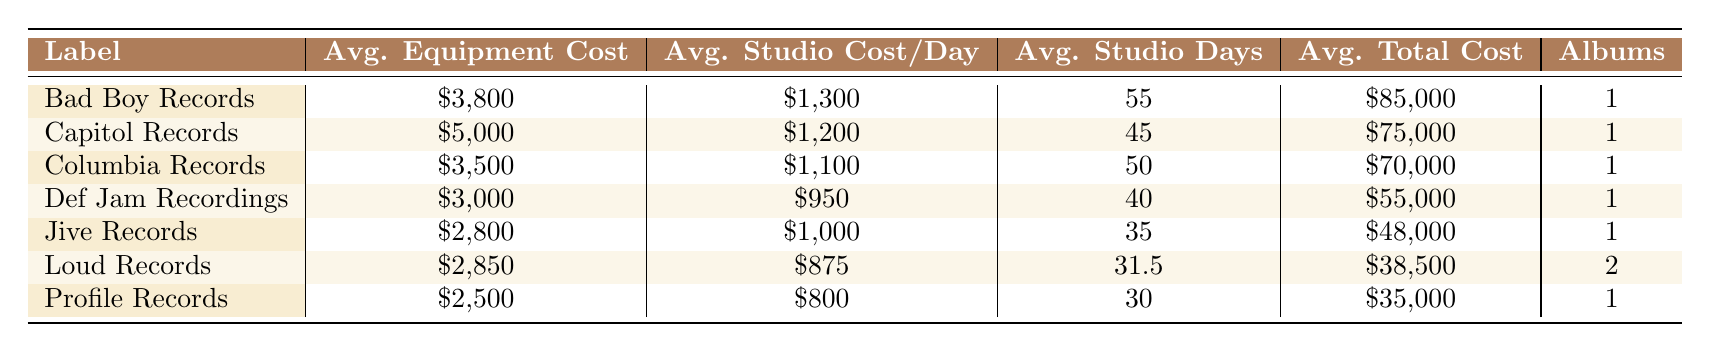What is the average equipment cost for Bad Boy Records? From the table, Bad Boy Records has an average equipment cost of $3,800. This value is directly taken from the corresponding cell in the "Avg. Equipment Cost" column for Bad Boy Records.
Answer: 3,800 Which record label has the highest average total cost? By looking through the "Avg. Total Cost" column, Bad Boy Records has the highest average total cost of $85,000 compared to other labels. This is the only value provided for Bad Boy Records, so it stands out.
Answer: Bad Boy Records What is the average number of studio days for albums produced by Loud Records? Loud Records has two albums listed, with a combined total of (25 + 38) studio days which equals 63 days. To find the average, we divide this by the number of albums, so 63/2 = 31.5 days.
Answer: 31.5 Is the average studio cost per day for Capitol Records greater than that for Jive Records? According to the table, Capitol Records has an average studio cost per day of $1,200, while Jive Records has an average of $1,000. Since $1,200 is greater than $1,000, the statement is true.
Answer: Yes Which record label has the lowest average equipment cost, and what is that cost? The values in the "Avg. Equipment Cost" column show that Profile Records has the lowest average equipment cost at $2,500. This value is directly found in the column for Profile Records.
Answer: Profile Records, 2,500 What is the difference in average total cost between Def Jam Recordings and Loud Records? The average total cost for Def Jam Recordings is $55,000, and for Loud Records, it is $38,500. To find the difference, subtract the latter from the former: 55,000 - 38,500 = 16,500.
Answer: 16,500 Does Capitol Records produce more albums on average than Profile Records? The table shows that Capitol Records has produced 1 album, just like Profile Records. Therefore, neither has a greater average number of albums produced.
Answer: No What is the combined average studio cost per day for all record labels listed? To find the combined average studio cost per day, add the individual averages: (1300 + 1200 + 1100 + 950 + 1000 + 875 + 800) = 8,225. The number of labels is 7, so we divide 8225 by 7, yielding an average of approximately 1,176.43.
Answer: Approximately 1,176.43 